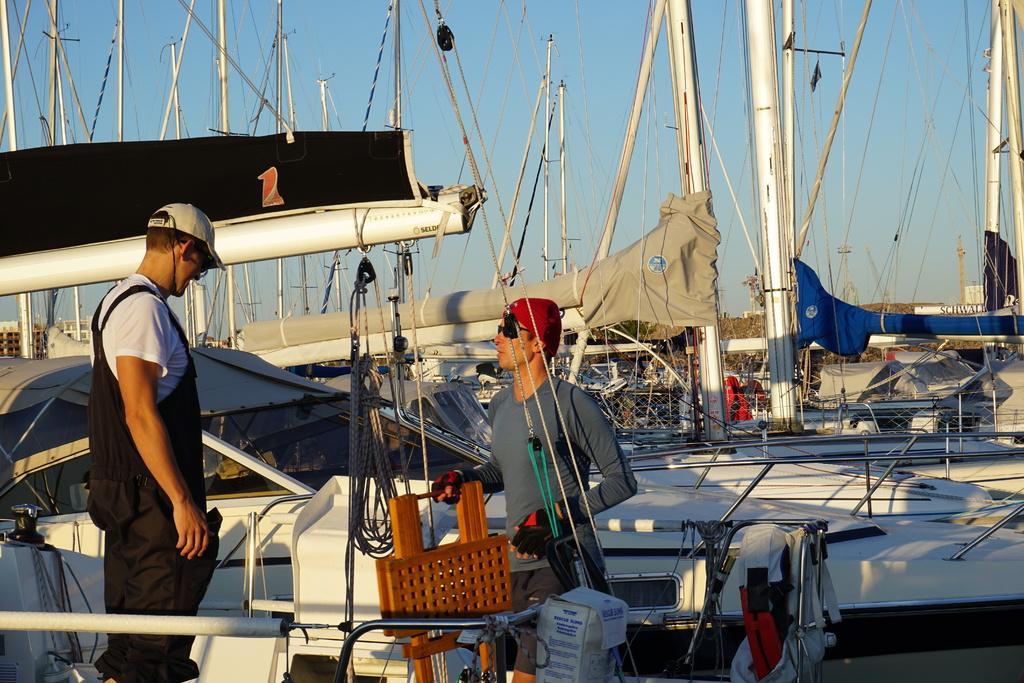Describe this image in one or two sentences. In this image there are two people standing, and there are some ships and in the ships there are some wires, baskets, clothes, boards, boxes, poles and some other objects. And in the background there are poles and wires, at the top there is sky. 